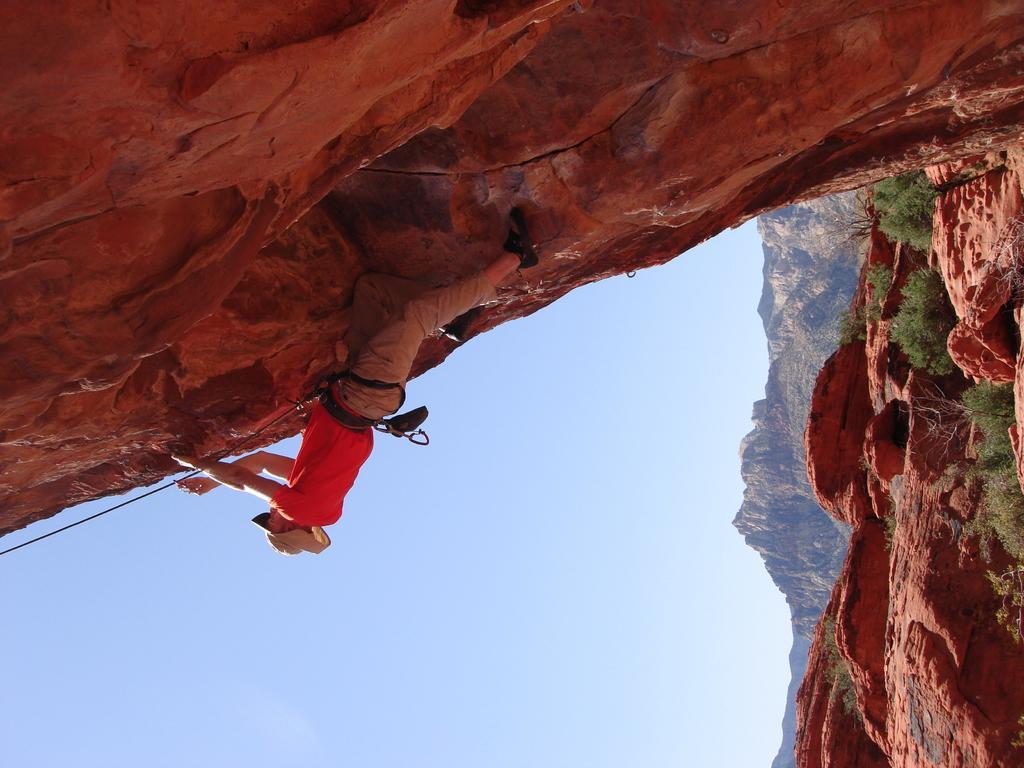Can you describe this image briefly? In this image, I can see the man holding the rope and climbing the hill. He wore a hat, red T-shirt, trouser and shoes. These are the small trees. 